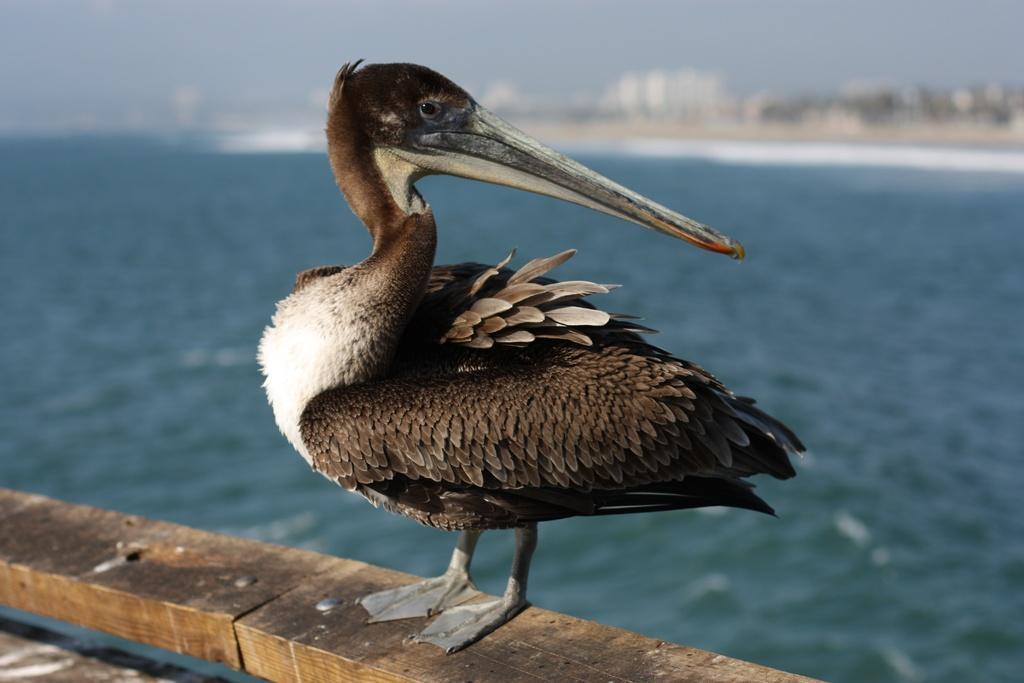Could you give a brief overview of what you see in this image? In this image we can see a bird called brown pelican which is on the wooden surface and in the background of the image we can see water and some buildings. 